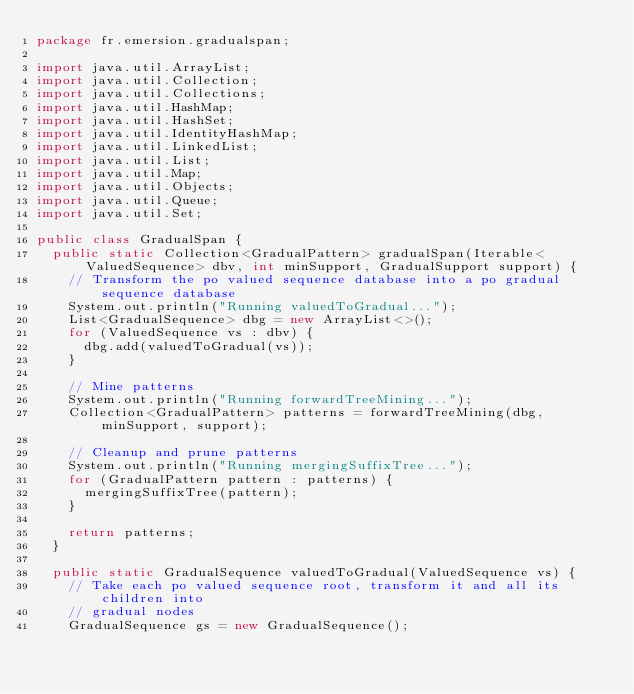<code> <loc_0><loc_0><loc_500><loc_500><_Java_>package fr.emersion.gradualspan;

import java.util.ArrayList;
import java.util.Collection;
import java.util.Collections;
import java.util.HashMap;
import java.util.HashSet;
import java.util.IdentityHashMap;
import java.util.LinkedList;
import java.util.List;
import java.util.Map;
import java.util.Objects;
import java.util.Queue;
import java.util.Set;

public class GradualSpan {
	public static Collection<GradualPattern> gradualSpan(Iterable<ValuedSequence> dbv, int minSupport, GradualSupport support) {
		// Transform the po valued sequence database into a po gradual sequence database
		System.out.println("Running valuedToGradual...");
		List<GradualSequence> dbg = new ArrayList<>();
		for (ValuedSequence vs : dbv) {
			dbg.add(valuedToGradual(vs));
		}

		// Mine patterns
		System.out.println("Running forwardTreeMining...");
		Collection<GradualPattern> patterns = forwardTreeMining(dbg, minSupport, support);

		// Cleanup and prune patterns
		System.out.println("Running mergingSuffixTree...");
		for (GradualPattern pattern : patterns) {
			mergingSuffixTree(pattern);
		}

		return patterns;
	}

	public static GradualSequence valuedToGradual(ValuedSequence vs) {
		// Take each po valued sequence root, transform it and all its children into
		// gradual nodes
		GradualSequence gs = new GradualSequence();</code> 